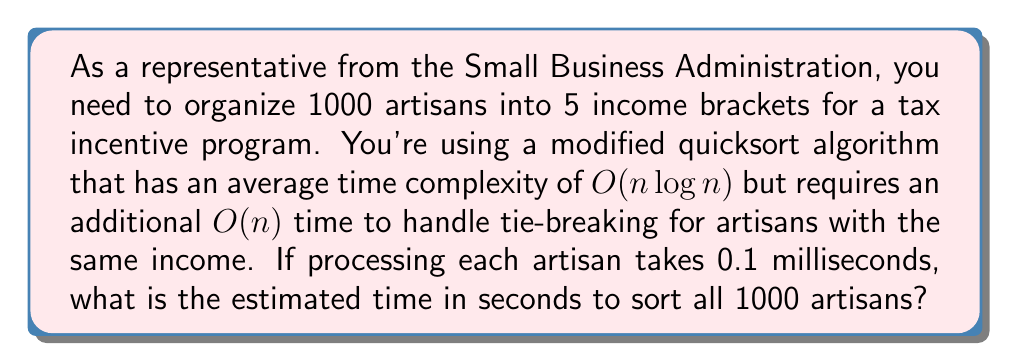Give your solution to this math problem. To solve this problem, we need to follow these steps:

1. Determine the time complexity of the algorithm:
   The total time complexity is $O(n \log n + n)$, which simplifies to $O(n \log n)$ as $n$ grows large.

2. Calculate $n \log n$ for $n = 1000$:
   $$1000 \log 1000 = 1000 \times \log_{10}(1000) \approx 1000 \times 3 = 3000$$

3. Add the linear component for tie-breaking:
   $$3000 + 1000 = 4000$$

4. Multiply by the processing time per artisan:
   $$4000 \times 0.1 \text{ ms} = 400 \text{ ms}$$

5. Convert milliseconds to seconds:
   $$400 \text{ ms} = 0.4 \text{ seconds}$$

Therefore, the estimated time to sort all 1000 artisans is approximately 0.4 seconds.
Answer: 0.4 seconds 